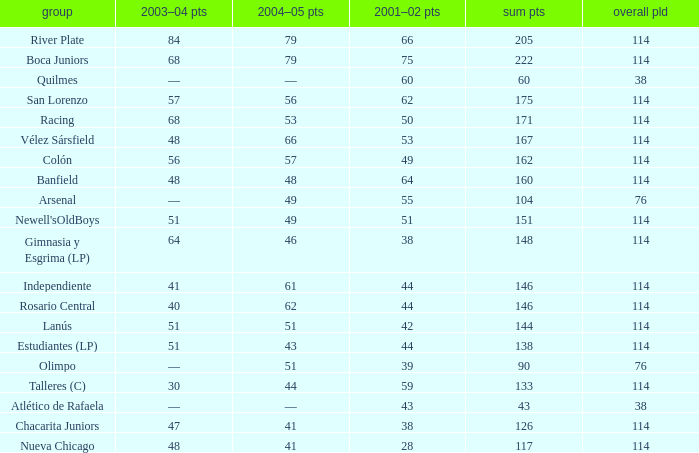Which Total Pts have a 2001–02 Pts smaller than 38? 117.0. 